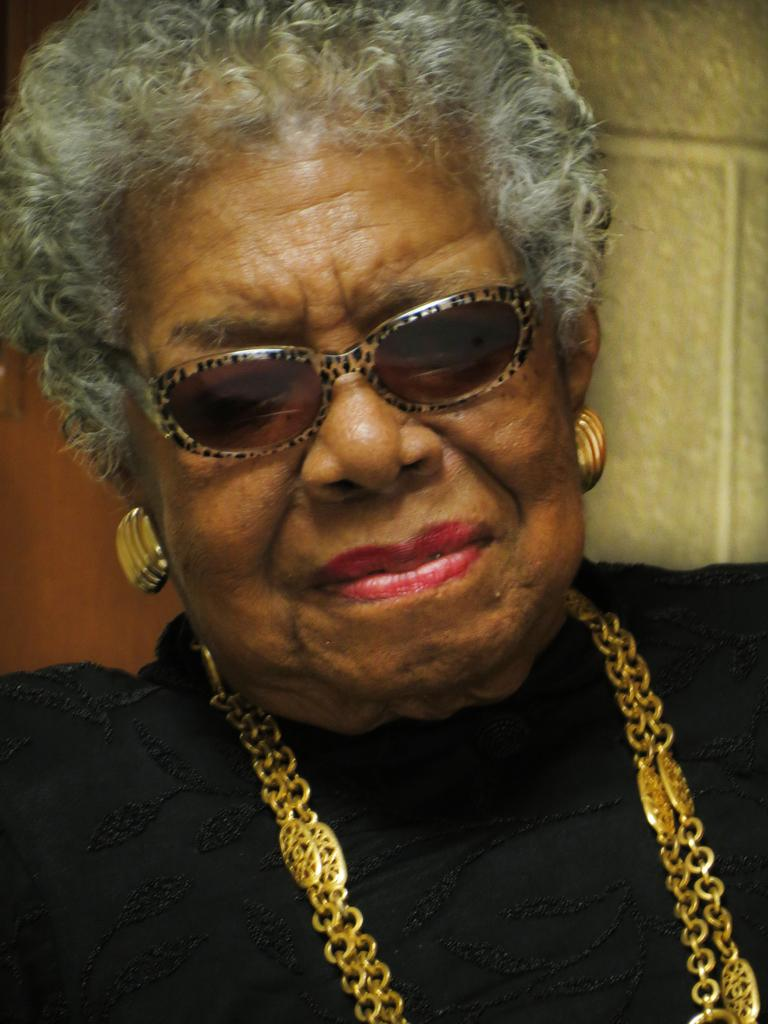Who is the main subject in the image? There is a woman in the center of the image. What accessories is the woman wearing? The woman is wearing a gold chain and gold earrings. What type of eyewear is the woman wearing? The woman is wearing sunglasses. What can be seen in the background of the image? There is a wall in the background of the image. What color is the pet that is visible in the image? There is no pet present in the image. What arithmetic problem is the woman solving in the image? There is no indication of the woman solving an arithmetic problem in the image. 